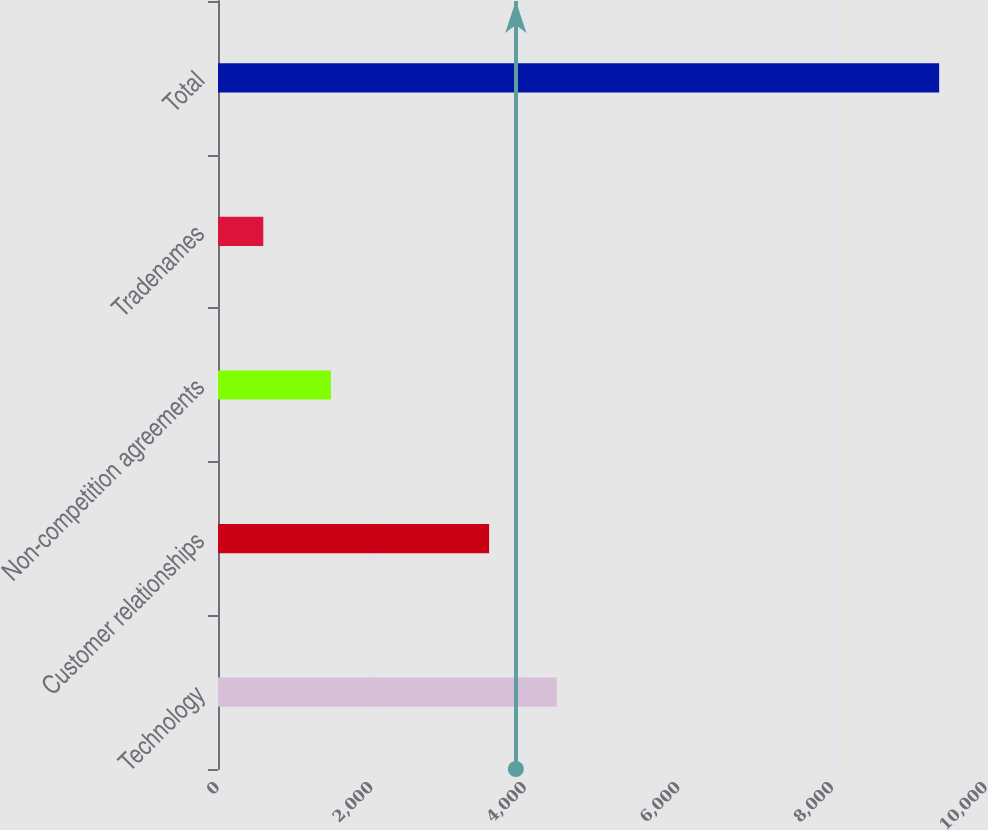Convert chart. <chart><loc_0><loc_0><loc_500><loc_500><bar_chart><fcel>Technology<fcel>Customer relationships<fcel>Non-competition agreements<fcel>Tradenames<fcel>Total<nl><fcel>4410<fcel>3530<fcel>1470<fcel>590<fcel>9390<nl></chart> 